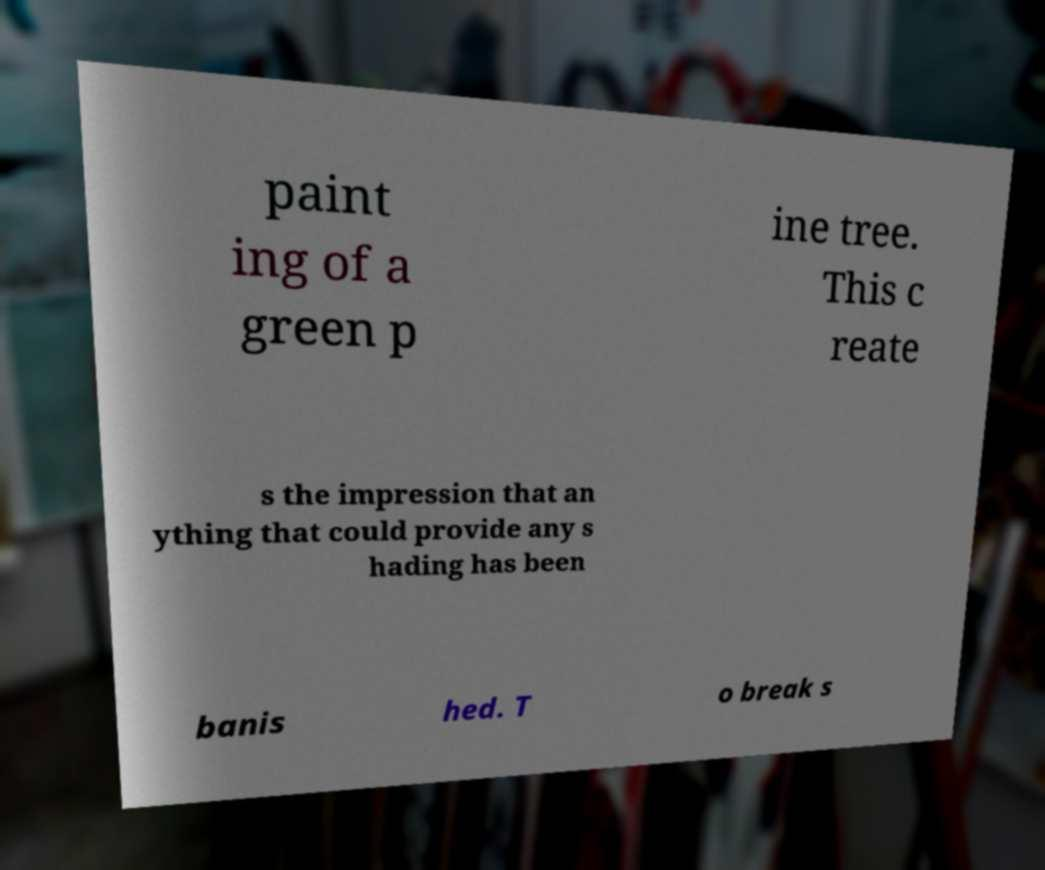Can you accurately transcribe the text from the provided image for me? paint ing of a green p ine tree. This c reate s the impression that an ything that could provide any s hading has been banis hed. T o break s 